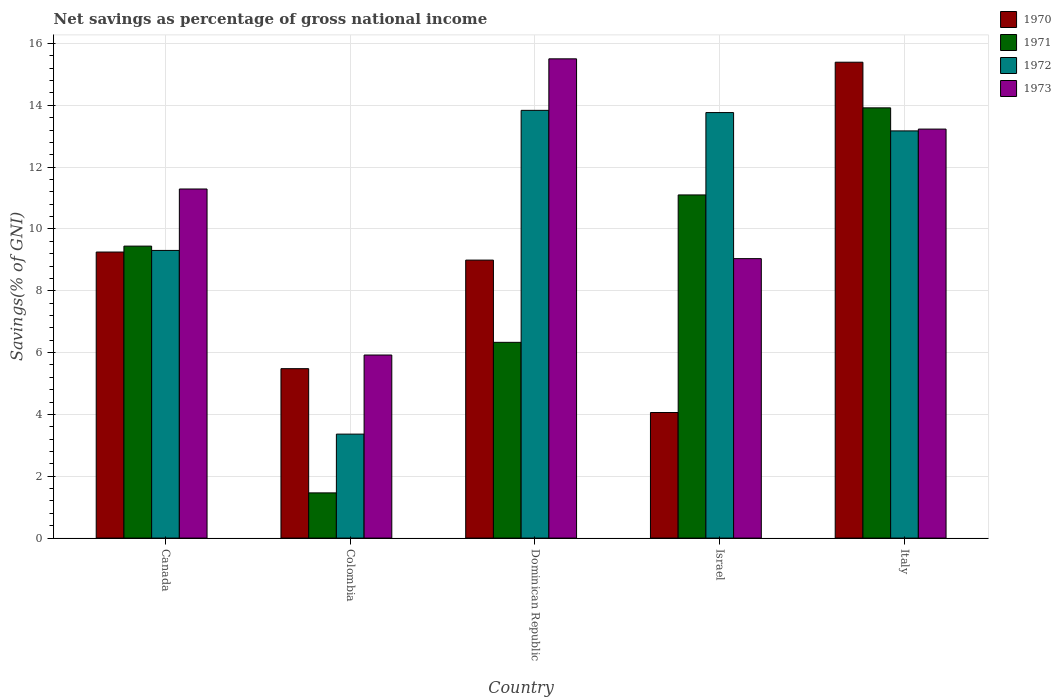Are the number of bars per tick equal to the number of legend labels?
Offer a very short reply. Yes. How many bars are there on the 5th tick from the right?
Provide a succinct answer. 4. What is the total savings in 1972 in Dominican Republic?
Provide a short and direct response. 13.84. Across all countries, what is the maximum total savings in 1972?
Keep it short and to the point. 13.84. Across all countries, what is the minimum total savings in 1971?
Offer a very short reply. 1.46. In which country was the total savings in 1973 maximum?
Ensure brevity in your answer.  Dominican Republic. What is the total total savings in 1972 in the graph?
Ensure brevity in your answer.  53.45. What is the difference between the total savings in 1970 in Colombia and that in Italy?
Ensure brevity in your answer.  -9.91. What is the difference between the total savings in 1970 in Colombia and the total savings in 1972 in Italy?
Your answer should be compact. -7.69. What is the average total savings in 1973 per country?
Provide a short and direct response. 11. What is the difference between the total savings of/in 1972 and total savings of/in 1973 in Dominican Republic?
Your answer should be compact. -1.67. In how many countries, is the total savings in 1970 greater than 0.4 %?
Provide a succinct answer. 5. What is the ratio of the total savings in 1970 in Israel to that in Italy?
Offer a terse response. 0.26. Is the difference between the total savings in 1972 in Colombia and Dominican Republic greater than the difference between the total savings in 1973 in Colombia and Dominican Republic?
Provide a succinct answer. No. What is the difference between the highest and the second highest total savings in 1971?
Keep it short and to the point. -1.66. What is the difference between the highest and the lowest total savings in 1973?
Ensure brevity in your answer.  9.58. Is it the case that in every country, the sum of the total savings in 1970 and total savings in 1972 is greater than the sum of total savings in 1971 and total savings in 1973?
Your answer should be very brief. No. What does the 4th bar from the right in Dominican Republic represents?
Provide a short and direct response. 1970. Is it the case that in every country, the sum of the total savings in 1973 and total savings in 1972 is greater than the total savings in 1971?
Offer a terse response. Yes. How many bars are there?
Offer a terse response. 20. Are the values on the major ticks of Y-axis written in scientific E-notation?
Your response must be concise. No. How are the legend labels stacked?
Give a very brief answer. Vertical. What is the title of the graph?
Give a very brief answer. Net savings as percentage of gross national income. What is the label or title of the Y-axis?
Your answer should be very brief. Savings(% of GNI). What is the Savings(% of GNI) of 1970 in Canada?
Ensure brevity in your answer.  9.25. What is the Savings(% of GNI) in 1971 in Canada?
Give a very brief answer. 9.45. What is the Savings(% of GNI) in 1972 in Canada?
Ensure brevity in your answer.  9.31. What is the Savings(% of GNI) of 1973 in Canada?
Your response must be concise. 11.29. What is the Savings(% of GNI) in 1970 in Colombia?
Your response must be concise. 5.48. What is the Savings(% of GNI) in 1971 in Colombia?
Your answer should be compact. 1.46. What is the Savings(% of GNI) in 1972 in Colombia?
Keep it short and to the point. 3.36. What is the Savings(% of GNI) of 1973 in Colombia?
Provide a short and direct response. 5.92. What is the Savings(% of GNI) of 1970 in Dominican Republic?
Provide a short and direct response. 8.99. What is the Savings(% of GNI) of 1971 in Dominican Republic?
Give a very brief answer. 6.33. What is the Savings(% of GNI) of 1972 in Dominican Republic?
Offer a very short reply. 13.84. What is the Savings(% of GNI) in 1973 in Dominican Republic?
Provide a succinct answer. 15.5. What is the Savings(% of GNI) of 1970 in Israel?
Your answer should be very brief. 4.06. What is the Savings(% of GNI) of 1971 in Israel?
Offer a terse response. 11.1. What is the Savings(% of GNI) of 1972 in Israel?
Offer a very short reply. 13.77. What is the Savings(% of GNI) in 1973 in Israel?
Give a very brief answer. 9.04. What is the Savings(% of GNI) of 1970 in Italy?
Keep it short and to the point. 15.4. What is the Savings(% of GNI) of 1971 in Italy?
Give a very brief answer. 13.92. What is the Savings(% of GNI) in 1972 in Italy?
Make the answer very short. 13.17. What is the Savings(% of GNI) of 1973 in Italy?
Your response must be concise. 13.23. Across all countries, what is the maximum Savings(% of GNI) of 1970?
Make the answer very short. 15.4. Across all countries, what is the maximum Savings(% of GNI) of 1971?
Your answer should be very brief. 13.92. Across all countries, what is the maximum Savings(% of GNI) in 1972?
Your answer should be very brief. 13.84. Across all countries, what is the maximum Savings(% of GNI) in 1973?
Your answer should be compact. 15.5. Across all countries, what is the minimum Savings(% of GNI) of 1970?
Your answer should be very brief. 4.06. Across all countries, what is the minimum Savings(% of GNI) in 1971?
Your answer should be compact. 1.46. Across all countries, what is the minimum Savings(% of GNI) of 1972?
Give a very brief answer. 3.36. Across all countries, what is the minimum Savings(% of GNI) in 1973?
Provide a succinct answer. 5.92. What is the total Savings(% of GNI) of 1970 in the graph?
Make the answer very short. 43.19. What is the total Savings(% of GNI) of 1971 in the graph?
Your answer should be compact. 42.26. What is the total Savings(% of GNI) of 1972 in the graph?
Offer a terse response. 53.45. What is the total Savings(% of GNI) in 1973 in the graph?
Your answer should be very brief. 54.99. What is the difference between the Savings(% of GNI) in 1970 in Canada and that in Colombia?
Offer a very short reply. 3.77. What is the difference between the Savings(% of GNI) in 1971 in Canada and that in Colombia?
Your answer should be very brief. 7.98. What is the difference between the Savings(% of GNI) in 1972 in Canada and that in Colombia?
Offer a terse response. 5.94. What is the difference between the Savings(% of GNI) in 1973 in Canada and that in Colombia?
Provide a short and direct response. 5.37. What is the difference between the Savings(% of GNI) in 1970 in Canada and that in Dominican Republic?
Make the answer very short. 0.26. What is the difference between the Savings(% of GNI) of 1971 in Canada and that in Dominican Republic?
Make the answer very short. 3.11. What is the difference between the Savings(% of GNI) of 1972 in Canada and that in Dominican Republic?
Give a very brief answer. -4.53. What is the difference between the Savings(% of GNI) of 1973 in Canada and that in Dominican Republic?
Your response must be concise. -4.21. What is the difference between the Savings(% of GNI) in 1970 in Canada and that in Israel?
Your answer should be very brief. 5.19. What is the difference between the Savings(% of GNI) in 1971 in Canada and that in Israel?
Make the answer very short. -1.66. What is the difference between the Savings(% of GNI) of 1972 in Canada and that in Israel?
Give a very brief answer. -4.46. What is the difference between the Savings(% of GNI) in 1973 in Canada and that in Israel?
Your response must be concise. 2.25. What is the difference between the Savings(% of GNI) in 1970 in Canada and that in Italy?
Offer a terse response. -6.14. What is the difference between the Savings(% of GNI) in 1971 in Canada and that in Italy?
Keep it short and to the point. -4.47. What is the difference between the Savings(% of GNI) in 1972 in Canada and that in Italy?
Make the answer very short. -3.87. What is the difference between the Savings(% of GNI) of 1973 in Canada and that in Italy?
Provide a short and direct response. -1.94. What is the difference between the Savings(% of GNI) in 1970 in Colombia and that in Dominican Republic?
Make the answer very short. -3.51. What is the difference between the Savings(% of GNI) of 1971 in Colombia and that in Dominican Republic?
Provide a short and direct response. -4.87. What is the difference between the Savings(% of GNI) of 1972 in Colombia and that in Dominican Republic?
Offer a terse response. -10.47. What is the difference between the Savings(% of GNI) in 1973 in Colombia and that in Dominican Republic?
Give a very brief answer. -9.58. What is the difference between the Savings(% of GNI) in 1970 in Colombia and that in Israel?
Offer a terse response. 1.42. What is the difference between the Savings(% of GNI) of 1971 in Colombia and that in Israel?
Provide a succinct answer. -9.64. What is the difference between the Savings(% of GNI) in 1972 in Colombia and that in Israel?
Provide a succinct answer. -10.4. What is the difference between the Savings(% of GNI) of 1973 in Colombia and that in Israel?
Provide a succinct answer. -3.12. What is the difference between the Savings(% of GNI) of 1970 in Colombia and that in Italy?
Your answer should be very brief. -9.91. What is the difference between the Savings(% of GNI) in 1971 in Colombia and that in Italy?
Provide a short and direct response. -12.46. What is the difference between the Savings(% of GNI) of 1972 in Colombia and that in Italy?
Ensure brevity in your answer.  -9.81. What is the difference between the Savings(% of GNI) of 1973 in Colombia and that in Italy?
Keep it short and to the point. -7.31. What is the difference between the Savings(% of GNI) in 1970 in Dominican Republic and that in Israel?
Your answer should be compact. 4.93. What is the difference between the Savings(% of GNI) of 1971 in Dominican Republic and that in Israel?
Offer a very short reply. -4.77. What is the difference between the Savings(% of GNI) of 1972 in Dominican Republic and that in Israel?
Ensure brevity in your answer.  0.07. What is the difference between the Savings(% of GNI) in 1973 in Dominican Republic and that in Israel?
Give a very brief answer. 6.46. What is the difference between the Savings(% of GNI) of 1970 in Dominican Republic and that in Italy?
Ensure brevity in your answer.  -6.4. What is the difference between the Savings(% of GNI) in 1971 in Dominican Republic and that in Italy?
Your answer should be compact. -7.59. What is the difference between the Savings(% of GNI) of 1972 in Dominican Republic and that in Italy?
Offer a very short reply. 0.66. What is the difference between the Savings(% of GNI) in 1973 in Dominican Republic and that in Italy?
Make the answer very short. 2.27. What is the difference between the Savings(% of GNI) in 1970 in Israel and that in Italy?
Provide a succinct answer. -11.33. What is the difference between the Savings(% of GNI) of 1971 in Israel and that in Italy?
Give a very brief answer. -2.82. What is the difference between the Savings(% of GNI) in 1972 in Israel and that in Italy?
Your response must be concise. 0.59. What is the difference between the Savings(% of GNI) of 1973 in Israel and that in Italy?
Provide a succinct answer. -4.19. What is the difference between the Savings(% of GNI) of 1970 in Canada and the Savings(% of GNI) of 1971 in Colombia?
Make the answer very short. 7.79. What is the difference between the Savings(% of GNI) in 1970 in Canada and the Savings(% of GNI) in 1972 in Colombia?
Ensure brevity in your answer.  5.89. What is the difference between the Savings(% of GNI) of 1970 in Canada and the Savings(% of GNI) of 1973 in Colombia?
Make the answer very short. 3.33. What is the difference between the Savings(% of GNI) in 1971 in Canada and the Savings(% of GNI) in 1972 in Colombia?
Make the answer very short. 6.08. What is the difference between the Savings(% of GNI) in 1971 in Canada and the Savings(% of GNI) in 1973 in Colombia?
Your answer should be very brief. 3.52. What is the difference between the Savings(% of GNI) of 1972 in Canada and the Savings(% of GNI) of 1973 in Colombia?
Your answer should be compact. 3.38. What is the difference between the Savings(% of GNI) in 1970 in Canada and the Savings(% of GNI) in 1971 in Dominican Republic?
Your response must be concise. 2.92. What is the difference between the Savings(% of GNI) of 1970 in Canada and the Savings(% of GNI) of 1972 in Dominican Republic?
Make the answer very short. -4.58. What is the difference between the Savings(% of GNI) in 1970 in Canada and the Savings(% of GNI) in 1973 in Dominican Republic?
Provide a succinct answer. -6.25. What is the difference between the Savings(% of GNI) of 1971 in Canada and the Savings(% of GNI) of 1972 in Dominican Republic?
Provide a succinct answer. -4.39. What is the difference between the Savings(% of GNI) in 1971 in Canada and the Savings(% of GNI) in 1973 in Dominican Republic?
Keep it short and to the point. -6.06. What is the difference between the Savings(% of GNI) in 1972 in Canada and the Savings(% of GNI) in 1973 in Dominican Republic?
Provide a short and direct response. -6.2. What is the difference between the Savings(% of GNI) of 1970 in Canada and the Savings(% of GNI) of 1971 in Israel?
Give a very brief answer. -1.85. What is the difference between the Savings(% of GNI) in 1970 in Canada and the Savings(% of GNI) in 1972 in Israel?
Provide a succinct answer. -4.51. What is the difference between the Savings(% of GNI) of 1970 in Canada and the Savings(% of GNI) of 1973 in Israel?
Make the answer very short. 0.21. What is the difference between the Savings(% of GNI) in 1971 in Canada and the Savings(% of GNI) in 1972 in Israel?
Your answer should be compact. -4.32. What is the difference between the Savings(% of GNI) of 1971 in Canada and the Savings(% of GNI) of 1973 in Israel?
Provide a short and direct response. 0.4. What is the difference between the Savings(% of GNI) in 1972 in Canada and the Savings(% of GNI) in 1973 in Israel?
Keep it short and to the point. 0.27. What is the difference between the Savings(% of GNI) in 1970 in Canada and the Savings(% of GNI) in 1971 in Italy?
Offer a very short reply. -4.66. What is the difference between the Savings(% of GNI) in 1970 in Canada and the Savings(% of GNI) in 1972 in Italy?
Provide a succinct answer. -3.92. What is the difference between the Savings(% of GNI) of 1970 in Canada and the Savings(% of GNI) of 1973 in Italy?
Keep it short and to the point. -3.98. What is the difference between the Savings(% of GNI) in 1971 in Canada and the Savings(% of GNI) in 1972 in Italy?
Offer a terse response. -3.73. What is the difference between the Savings(% of GNI) of 1971 in Canada and the Savings(% of GNI) of 1973 in Italy?
Provide a short and direct response. -3.79. What is the difference between the Savings(% of GNI) in 1972 in Canada and the Savings(% of GNI) in 1973 in Italy?
Your response must be concise. -3.93. What is the difference between the Savings(% of GNI) in 1970 in Colombia and the Savings(% of GNI) in 1971 in Dominican Republic?
Your answer should be compact. -0.85. What is the difference between the Savings(% of GNI) in 1970 in Colombia and the Savings(% of GNI) in 1972 in Dominican Republic?
Provide a succinct answer. -8.36. What is the difference between the Savings(% of GNI) of 1970 in Colombia and the Savings(% of GNI) of 1973 in Dominican Republic?
Keep it short and to the point. -10.02. What is the difference between the Savings(% of GNI) in 1971 in Colombia and the Savings(% of GNI) in 1972 in Dominican Republic?
Offer a terse response. -12.38. What is the difference between the Savings(% of GNI) of 1971 in Colombia and the Savings(% of GNI) of 1973 in Dominican Republic?
Your response must be concise. -14.04. What is the difference between the Savings(% of GNI) of 1972 in Colombia and the Savings(% of GNI) of 1973 in Dominican Republic?
Your answer should be compact. -12.14. What is the difference between the Savings(% of GNI) of 1970 in Colombia and the Savings(% of GNI) of 1971 in Israel?
Ensure brevity in your answer.  -5.62. What is the difference between the Savings(% of GNI) of 1970 in Colombia and the Savings(% of GNI) of 1972 in Israel?
Ensure brevity in your answer.  -8.28. What is the difference between the Savings(% of GNI) of 1970 in Colombia and the Savings(% of GNI) of 1973 in Israel?
Keep it short and to the point. -3.56. What is the difference between the Savings(% of GNI) in 1971 in Colombia and the Savings(% of GNI) in 1972 in Israel?
Your answer should be compact. -12.3. What is the difference between the Savings(% of GNI) of 1971 in Colombia and the Savings(% of GNI) of 1973 in Israel?
Your answer should be very brief. -7.58. What is the difference between the Savings(% of GNI) of 1972 in Colombia and the Savings(% of GNI) of 1973 in Israel?
Offer a very short reply. -5.68. What is the difference between the Savings(% of GNI) of 1970 in Colombia and the Savings(% of GNI) of 1971 in Italy?
Your answer should be compact. -8.44. What is the difference between the Savings(% of GNI) in 1970 in Colombia and the Savings(% of GNI) in 1972 in Italy?
Keep it short and to the point. -7.69. What is the difference between the Savings(% of GNI) of 1970 in Colombia and the Savings(% of GNI) of 1973 in Italy?
Your answer should be very brief. -7.75. What is the difference between the Savings(% of GNI) in 1971 in Colombia and the Savings(% of GNI) in 1972 in Italy?
Your response must be concise. -11.71. What is the difference between the Savings(% of GNI) in 1971 in Colombia and the Savings(% of GNI) in 1973 in Italy?
Make the answer very short. -11.77. What is the difference between the Savings(% of GNI) of 1972 in Colombia and the Savings(% of GNI) of 1973 in Italy?
Offer a terse response. -9.87. What is the difference between the Savings(% of GNI) in 1970 in Dominican Republic and the Savings(% of GNI) in 1971 in Israel?
Your answer should be very brief. -2.11. What is the difference between the Savings(% of GNI) in 1970 in Dominican Republic and the Savings(% of GNI) in 1972 in Israel?
Your response must be concise. -4.77. What is the difference between the Savings(% of GNI) of 1970 in Dominican Republic and the Savings(% of GNI) of 1973 in Israel?
Give a very brief answer. -0.05. What is the difference between the Savings(% of GNI) in 1971 in Dominican Republic and the Savings(% of GNI) in 1972 in Israel?
Keep it short and to the point. -7.43. What is the difference between the Savings(% of GNI) of 1971 in Dominican Republic and the Savings(% of GNI) of 1973 in Israel?
Provide a succinct answer. -2.71. What is the difference between the Savings(% of GNI) in 1972 in Dominican Republic and the Savings(% of GNI) in 1973 in Israel?
Your answer should be very brief. 4.8. What is the difference between the Savings(% of GNI) in 1970 in Dominican Republic and the Savings(% of GNI) in 1971 in Italy?
Your answer should be very brief. -4.93. What is the difference between the Savings(% of GNI) in 1970 in Dominican Republic and the Savings(% of GNI) in 1972 in Italy?
Your response must be concise. -4.18. What is the difference between the Savings(% of GNI) of 1970 in Dominican Republic and the Savings(% of GNI) of 1973 in Italy?
Offer a very short reply. -4.24. What is the difference between the Savings(% of GNI) of 1971 in Dominican Republic and the Savings(% of GNI) of 1972 in Italy?
Keep it short and to the point. -6.84. What is the difference between the Savings(% of GNI) of 1971 in Dominican Republic and the Savings(% of GNI) of 1973 in Italy?
Provide a succinct answer. -6.9. What is the difference between the Savings(% of GNI) in 1972 in Dominican Republic and the Savings(% of GNI) in 1973 in Italy?
Give a very brief answer. 0.61. What is the difference between the Savings(% of GNI) of 1970 in Israel and the Savings(% of GNI) of 1971 in Italy?
Ensure brevity in your answer.  -9.86. What is the difference between the Savings(% of GNI) in 1970 in Israel and the Savings(% of GNI) in 1972 in Italy?
Your answer should be very brief. -9.11. What is the difference between the Savings(% of GNI) of 1970 in Israel and the Savings(% of GNI) of 1973 in Italy?
Provide a short and direct response. -9.17. What is the difference between the Savings(% of GNI) of 1971 in Israel and the Savings(% of GNI) of 1972 in Italy?
Give a very brief answer. -2.07. What is the difference between the Savings(% of GNI) in 1971 in Israel and the Savings(% of GNI) in 1973 in Italy?
Keep it short and to the point. -2.13. What is the difference between the Savings(% of GNI) in 1972 in Israel and the Savings(% of GNI) in 1973 in Italy?
Offer a very short reply. 0.53. What is the average Savings(% of GNI) of 1970 per country?
Provide a succinct answer. 8.64. What is the average Savings(% of GNI) in 1971 per country?
Ensure brevity in your answer.  8.45. What is the average Savings(% of GNI) in 1972 per country?
Your answer should be very brief. 10.69. What is the average Savings(% of GNI) in 1973 per country?
Offer a terse response. 11. What is the difference between the Savings(% of GNI) in 1970 and Savings(% of GNI) in 1971 in Canada?
Your answer should be very brief. -0.19. What is the difference between the Savings(% of GNI) in 1970 and Savings(% of GNI) in 1972 in Canada?
Your answer should be compact. -0.05. What is the difference between the Savings(% of GNI) of 1970 and Savings(% of GNI) of 1973 in Canada?
Your answer should be very brief. -2.04. What is the difference between the Savings(% of GNI) in 1971 and Savings(% of GNI) in 1972 in Canada?
Provide a succinct answer. 0.14. What is the difference between the Savings(% of GNI) in 1971 and Savings(% of GNI) in 1973 in Canada?
Provide a succinct answer. -1.85. What is the difference between the Savings(% of GNI) in 1972 and Savings(% of GNI) in 1973 in Canada?
Your answer should be compact. -1.99. What is the difference between the Savings(% of GNI) of 1970 and Savings(% of GNI) of 1971 in Colombia?
Ensure brevity in your answer.  4.02. What is the difference between the Savings(% of GNI) in 1970 and Savings(% of GNI) in 1972 in Colombia?
Ensure brevity in your answer.  2.12. What is the difference between the Savings(% of GNI) in 1970 and Savings(% of GNI) in 1973 in Colombia?
Your answer should be compact. -0.44. What is the difference between the Savings(% of GNI) in 1971 and Savings(% of GNI) in 1972 in Colombia?
Your answer should be very brief. -1.9. What is the difference between the Savings(% of GNI) in 1971 and Savings(% of GNI) in 1973 in Colombia?
Your answer should be very brief. -4.46. What is the difference between the Savings(% of GNI) of 1972 and Savings(% of GNI) of 1973 in Colombia?
Make the answer very short. -2.56. What is the difference between the Savings(% of GNI) in 1970 and Savings(% of GNI) in 1971 in Dominican Republic?
Give a very brief answer. 2.66. What is the difference between the Savings(% of GNI) in 1970 and Savings(% of GNI) in 1972 in Dominican Republic?
Your answer should be very brief. -4.84. What is the difference between the Savings(% of GNI) of 1970 and Savings(% of GNI) of 1973 in Dominican Republic?
Offer a terse response. -6.51. What is the difference between the Savings(% of GNI) of 1971 and Savings(% of GNI) of 1972 in Dominican Republic?
Make the answer very short. -7.5. What is the difference between the Savings(% of GNI) in 1971 and Savings(% of GNI) in 1973 in Dominican Republic?
Your answer should be compact. -9.17. What is the difference between the Savings(% of GNI) of 1972 and Savings(% of GNI) of 1973 in Dominican Republic?
Your response must be concise. -1.67. What is the difference between the Savings(% of GNI) in 1970 and Savings(% of GNI) in 1971 in Israel?
Make the answer very short. -7.04. What is the difference between the Savings(% of GNI) of 1970 and Savings(% of GNI) of 1972 in Israel?
Ensure brevity in your answer.  -9.7. What is the difference between the Savings(% of GNI) in 1970 and Savings(% of GNI) in 1973 in Israel?
Your answer should be compact. -4.98. What is the difference between the Savings(% of GNI) of 1971 and Savings(% of GNI) of 1972 in Israel?
Offer a terse response. -2.66. What is the difference between the Savings(% of GNI) of 1971 and Savings(% of GNI) of 1973 in Israel?
Your answer should be very brief. 2.06. What is the difference between the Savings(% of GNI) in 1972 and Savings(% of GNI) in 1973 in Israel?
Your answer should be very brief. 4.73. What is the difference between the Savings(% of GNI) in 1970 and Savings(% of GNI) in 1971 in Italy?
Make the answer very short. 1.48. What is the difference between the Savings(% of GNI) in 1970 and Savings(% of GNI) in 1972 in Italy?
Provide a succinct answer. 2.22. What is the difference between the Savings(% of GNI) of 1970 and Savings(% of GNI) of 1973 in Italy?
Your response must be concise. 2.16. What is the difference between the Savings(% of GNI) of 1971 and Savings(% of GNI) of 1972 in Italy?
Your response must be concise. 0.75. What is the difference between the Savings(% of GNI) of 1971 and Savings(% of GNI) of 1973 in Italy?
Offer a very short reply. 0.69. What is the difference between the Savings(% of GNI) in 1972 and Savings(% of GNI) in 1973 in Italy?
Your response must be concise. -0.06. What is the ratio of the Savings(% of GNI) of 1970 in Canada to that in Colombia?
Your answer should be very brief. 1.69. What is the ratio of the Savings(% of GNI) in 1971 in Canada to that in Colombia?
Ensure brevity in your answer.  6.46. What is the ratio of the Savings(% of GNI) of 1972 in Canada to that in Colombia?
Give a very brief answer. 2.77. What is the ratio of the Savings(% of GNI) in 1973 in Canada to that in Colombia?
Ensure brevity in your answer.  1.91. What is the ratio of the Savings(% of GNI) in 1970 in Canada to that in Dominican Republic?
Give a very brief answer. 1.03. What is the ratio of the Savings(% of GNI) of 1971 in Canada to that in Dominican Republic?
Offer a terse response. 1.49. What is the ratio of the Savings(% of GNI) in 1972 in Canada to that in Dominican Republic?
Give a very brief answer. 0.67. What is the ratio of the Savings(% of GNI) of 1973 in Canada to that in Dominican Republic?
Your answer should be compact. 0.73. What is the ratio of the Savings(% of GNI) in 1970 in Canada to that in Israel?
Make the answer very short. 2.28. What is the ratio of the Savings(% of GNI) of 1971 in Canada to that in Israel?
Your response must be concise. 0.85. What is the ratio of the Savings(% of GNI) in 1972 in Canada to that in Israel?
Your answer should be compact. 0.68. What is the ratio of the Savings(% of GNI) of 1973 in Canada to that in Israel?
Give a very brief answer. 1.25. What is the ratio of the Savings(% of GNI) of 1970 in Canada to that in Italy?
Offer a very short reply. 0.6. What is the ratio of the Savings(% of GNI) of 1971 in Canada to that in Italy?
Your answer should be very brief. 0.68. What is the ratio of the Savings(% of GNI) in 1972 in Canada to that in Italy?
Keep it short and to the point. 0.71. What is the ratio of the Savings(% of GNI) in 1973 in Canada to that in Italy?
Your answer should be very brief. 0.85. What is the ratio of the Savings(% of GNI) in 1970 in Colombia to that in Dominican Republic?
Your answer should be very brief. 0.61. What is the ratio of the Savings(% of GNI) of 1971 in Colombia to that in Dominican Republic?
Offer a very short reply. 0.23. What is the ratio of the Savings(% of GNI) of 1972 in Colombia to that in Dominican Republic?
Offer a terse response. 0.24. What is the ratio of the Savings(% of GNI) of 1973 in Colombia to that in Dominican Republic?
Provide a short and direct response. 0.38. What is the ratio of the Savings(% of GNI) of 1970 in Colombia to that in Israel?
Make the answer very short. 1.35. What is the ratio of the Savings(% of GNI) in 1971 in Colombia to that in Israel?
Offer a very short reply. 0.13. What is the ratio of the Savings(% of GNI) in 1972 in Colombia to that in Israel?
Offer a terse response. 0.24. What is the ratio of the Savings(% of GNI) in 1973 in Colombia to that in Israel?
Your answer should be very brief. 0.66. What is the ratio of the Savings(% of GNI) of 1970 in Colombia to that in Italy?
Offer a terse response. 0.36. What is the ratio of the Savings(% of GNI) in 1971 in Colombia to that in Italy?
Offer a terse response. 0.11. What is the ratio of the Savings(% of GNI) in 1972 in Colombia to that in Italy?
Provide a short and direct response. 0.26. What is the ratio of the Savings(% of GNI) in 1973 in Colombia to that in Italy?
Your answer should be very brief. 0.45. What is the ratio of the Savings(% of GNI) in 1970 in Dominican Republic to that in Israel?
Your answer should be compact. 2.21. What is the ratio of the Savings(% of GNI) in 1971 in Dominican Republic to that in Israel?
Provide a succinct answer. 0.57. What is the ratio of the Savings(% of GNI) of 1973 in Dominican Republic to that in Israel?
Give a very brief answer. 1.71. What is the ratio of the Savings(% of GNI) in 1970 in Dominican Republic to that in Italy?
Make the answer very short. 0.58. What is the ratio of the Savings(% of GNI) in 1971 in Dominican Republic to that in Italy?
Offer a very short reply. 0.46. What is the ratio of the Savings(% of GNI) in 1972 in Dominican Republic to that in Italy?
Offer a terse response. 1.05. What is the ratio of the Savings(% of GNI) in 1973 in Dominican Republic to that in Italy?
Ensure brevity in your answer.  1.17. What is the ratio of the Savings(% of GNI) of 1970 in Israel to that in Italy?
Your answer should be compact. 0.26. What is the ratio of the Savings(% of GNI) of 1971 in Israel to that in Italy?
Give a very brief answer. 0.8. What is the ratio of the Savings(% of GNI) in 1972 in Israel to that in Italy?
Give a very brief answer. 1.04. What is the ratio of the Savings(% of GNI) in 1973 in Israel to that in Italy?
Provide a succinct answer. 0.68. What is the difference between the highest and the second highest Savings(% of GNI) of 1970?
Offer a very short reply. 6.14. What is the difference between the highest and the second highest Savings(% of GNI) in 1971?
Keep it short and to the point. 2.82. What is the difference between the highest and the second highest Savings(% of GNI) of 1972?
Your response must be concise. 0.07. What is the difference between the highest and the second highest Savings(% of GNI) of 1973?
Offer a terse response. 2.27. What is the difference between the highest and the lowest Savings(% of GNI) in 1970?
Offer a terse response. 11.33. What is the difference between the highest and the lowest Savings(% of GNI) in 1971?
Provide a succinct answer. 12.46. What is the difference between the highest and the lowest Savings(% of GNI) of 1972?
Keep it short and to the point. 10.47. What is the difference between the highest and the lowest Savings(% of GNI) of 1973?
Ensure brevity in your answer.  9.58. 